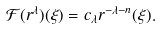Convert formula to latex. <formula><loc_0><loc_0><loc_500><loc_500>\mathcal { F } ( r ^ { \lambda } ) ( \xi ) = c _ { \lambda } r ^ { - \lambda - n } ( \xi ) .</formula> 